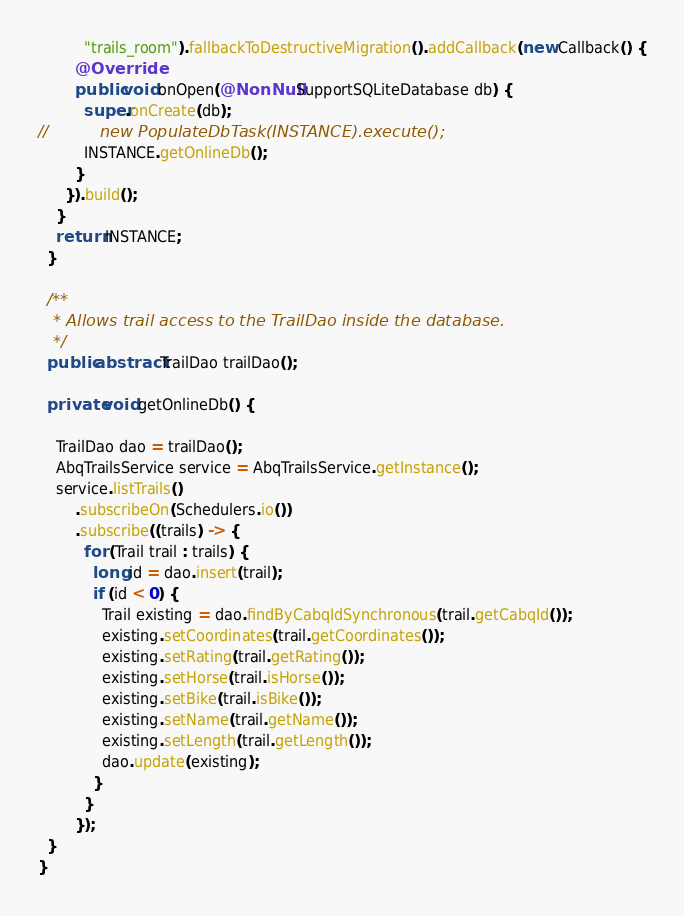Convert code to text. <code><loc_0><loc_0><loc_500><loc_500><_Java_>          "trails_room").fallbackToDestructiveMigration().addCallback(new Callback() {
        @Override
        public void onOpen(@NonNull SupportSQLiteDatabase db) {
          super.onCreate(db);
//          new PopulateDbTask(INSTANCE).execute();
          INSTANCE.getOnlineDb();
        }
      }).build();
    }
    return INSTANCE;
  }

  /**
   * Allows trail access to the TrailDao inside the database.
   */
  public abstract TrailDao trailDao();

  private void getOnlineDb() {

    TrailDao dao = trailDao();
    AbqTrailsService service = AbqTrailsService.getInstance();
    service.listTrails()
        .subscribeOn(Schedulers.io())
        .subscribe((trails) -> {
          for (Trail trail : trails) {
            long id = dao.insert(trail);
            if (id < 0) {
              Trail existing = dao.findByCabqIdSynchronous(trail.getCabqId());
              existing.setCoordinates(trail.getCoordinates());
              existing.setRating(trail.getRating());
              existing.setHorse(trail.isHorse());
              existing.setBike(trail.isBike());
              existing.setName(trail.getName());
              existing.setLength(trail.getLength());
              dao.update(existing);
            }
          }
        });
  }
}
</code> 